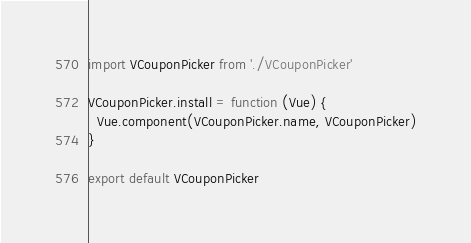<code> <loc_0><loc_0><loc_500><loc_500><_JavaScript_>import VCouponPicker from './VCouponPicker'

VCouponPicker.install = function (Vue) {
  Vue.component(VCouponPicker.name, VCouponPicker)
}

export default VCouponPicker
</code> 